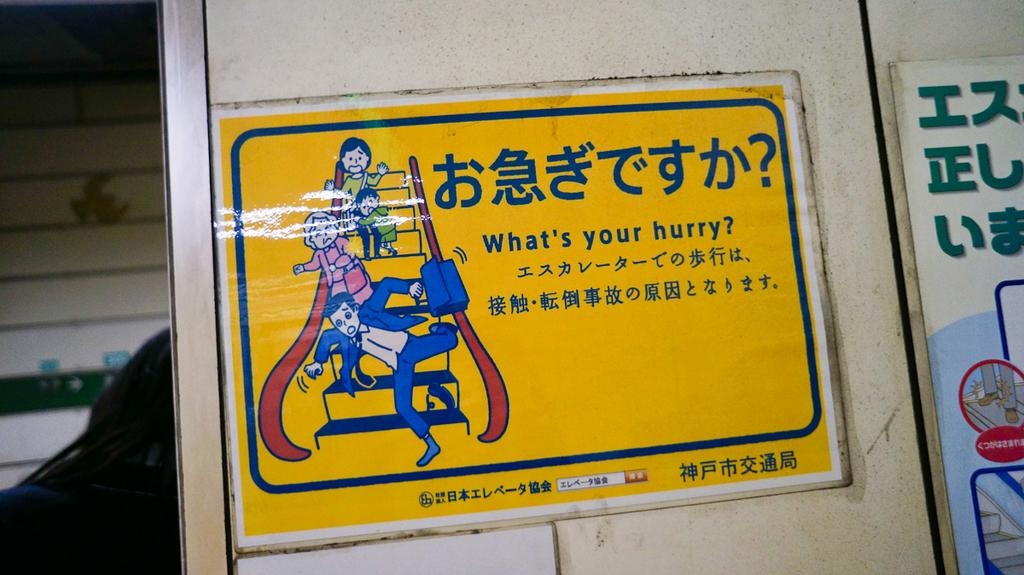<image>
Write a terse but informative summary of the picture. A sign in yellow on which the words what's your hurry? are visible. 